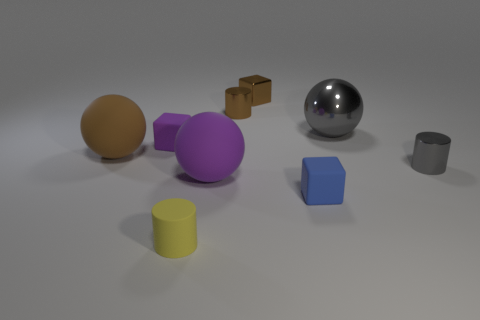There is a sphere that is in front of the metallic cylinder that is right of the metal cylinder that is behind the tiny purple object; what is its color?
Provide a short and direct response. Purple. There is a purple rubber object that is in front of the small gray thing; does it have the same shape as the tiny yellow thing?
Your answer should be compact. No. What number of blue matte cubes are there?
Your response must be concise. 1. What number of yellow cylinders are the same size as the metal block?
Provide a succinct answer. 1. What material is the large gray ball?
Provide a short and direct response. Metal. Do the matte cylinder and the large sphere on the right side of the small blue matte cube have the same color?
Provide a short and direct response. No. Is there anything else that is the same size as the blue thing?
Provide a short and direct response. Yes. There is a cube that is in front of the brown cylinder and left of the blue block; how big is it?
Keep it short and to the point. Small. What shape is the big purple thing that is the same material as the tiny blue object?
Offer a very short reply. Sphere. Are the brown ball and the sphere right of the small blue matte thing made of the same material?
Your response must be concise. No. 